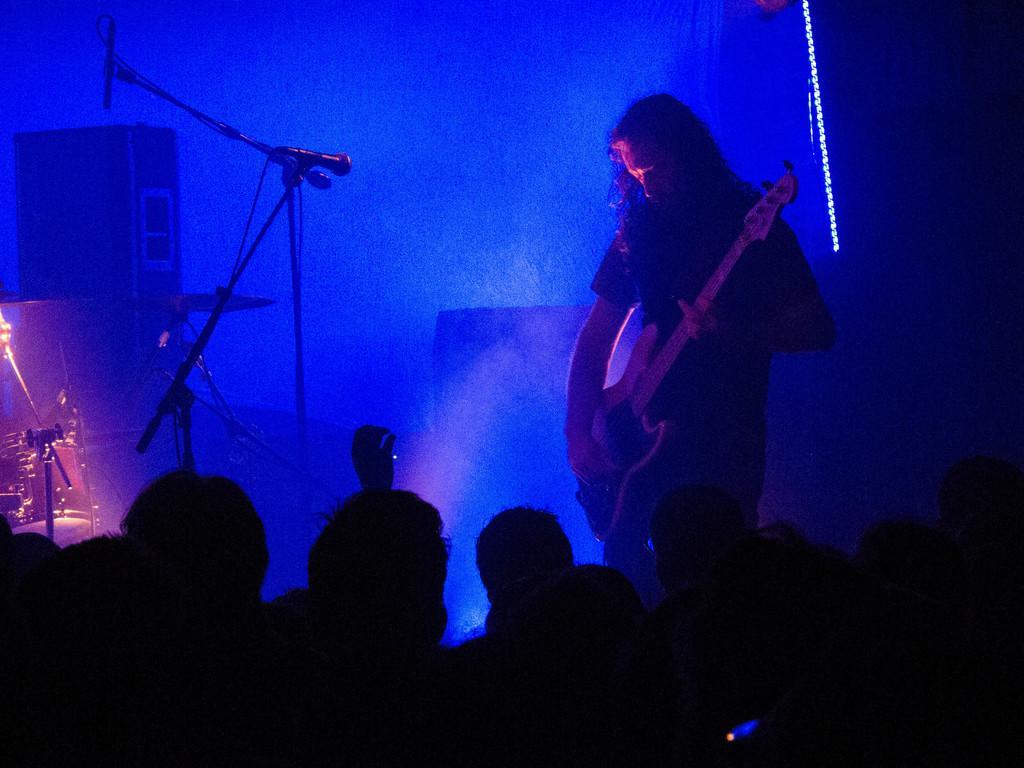Could you give a brief overview of what you see in this image? In this image we can see a man playing the guitar. We can also see the miles with the stands. We can also see the sound boxes and also the light and also the blue color focus light. At the bottom we can see the people. 